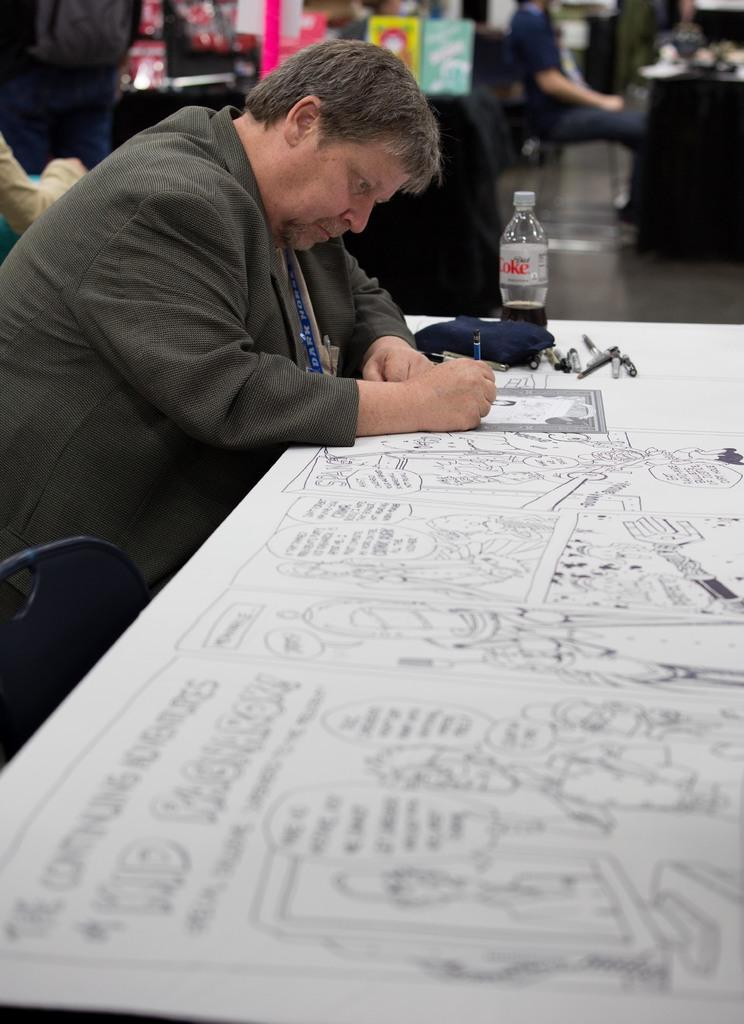What is the man in the image doing? The man is sitting on a chair and drawing a sketch on a table. What is on the table besides the sketch the man is drawing? There is a bottle, other sketches, and other unspecified items on the table. What is the man using to draw the sketch? The man is likely using a pencil or pen, but this is not specified in the facts. How much does the volcano weigh in the image? There is no volcano present in the image. What type of toad can be seen sitting on the man's shoulder in the image? There is no toad present in the image. 